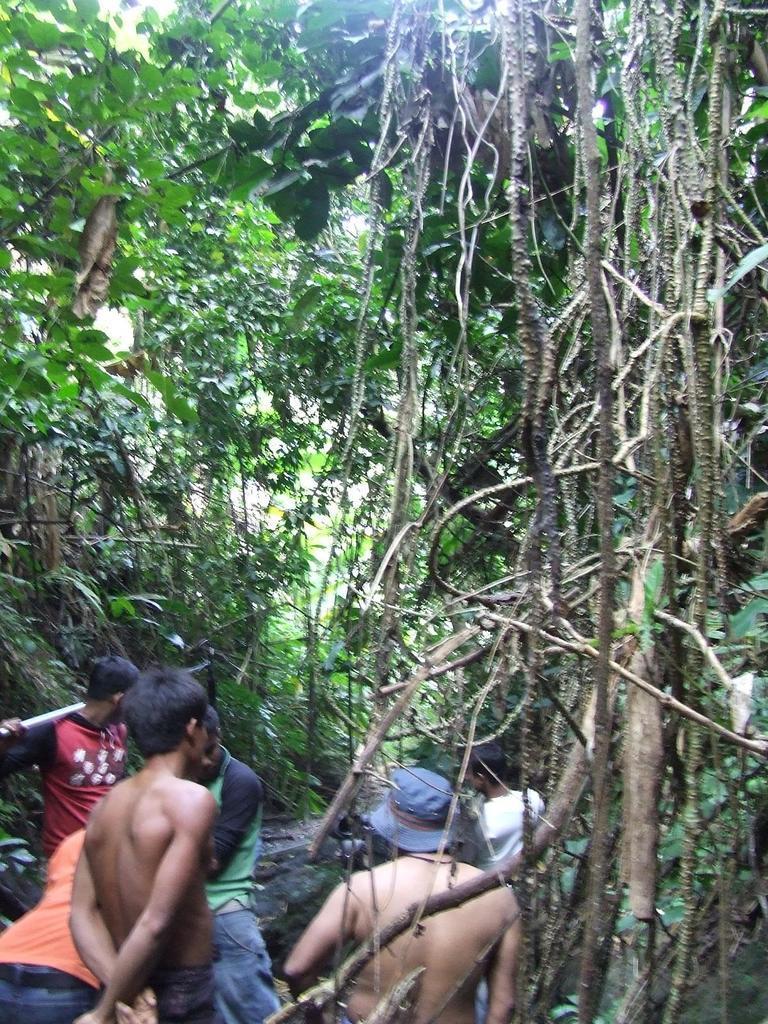Describe this image in one or two sentences. On the left side a group of persons are walking, in the middle there are trees in this image. 